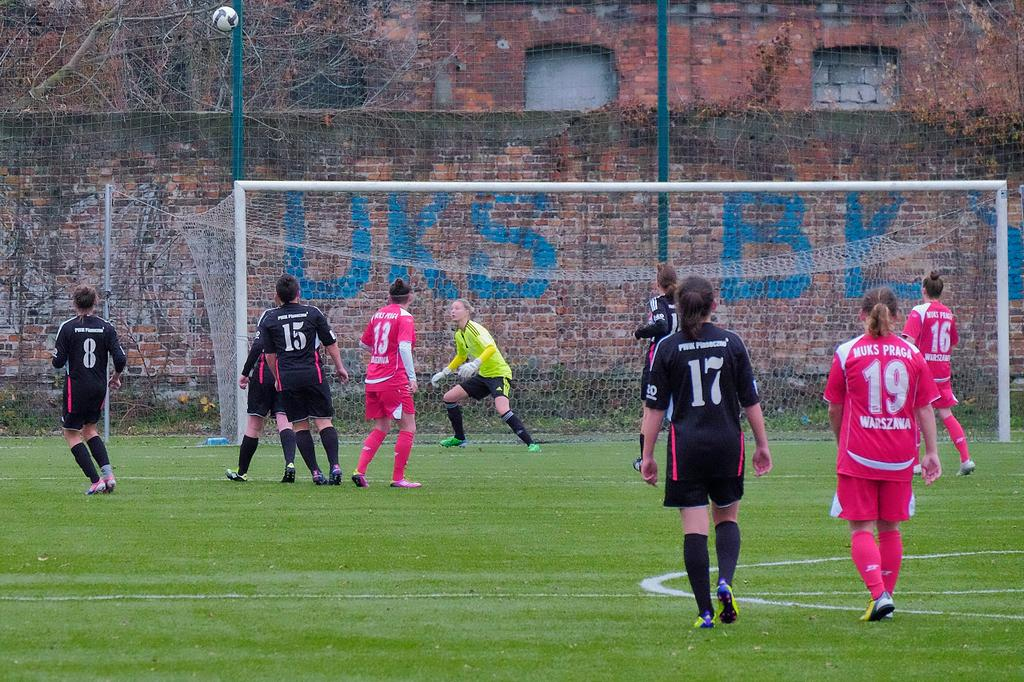<image>
Present a compact description of the photo's key features. Two teams of female soccer players are near the goal with one in pink having the number 19 on her back. 